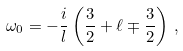Convert formula to latex. <formula><loc_0><loc_0><loc_500><loc_500>\omega _ { 0 } = - \frac { i } { l } \left ( \frac { 3 } { 2 } + \ell \mp \frac { 3 } { 2 } \right ) \, ,</formula> 